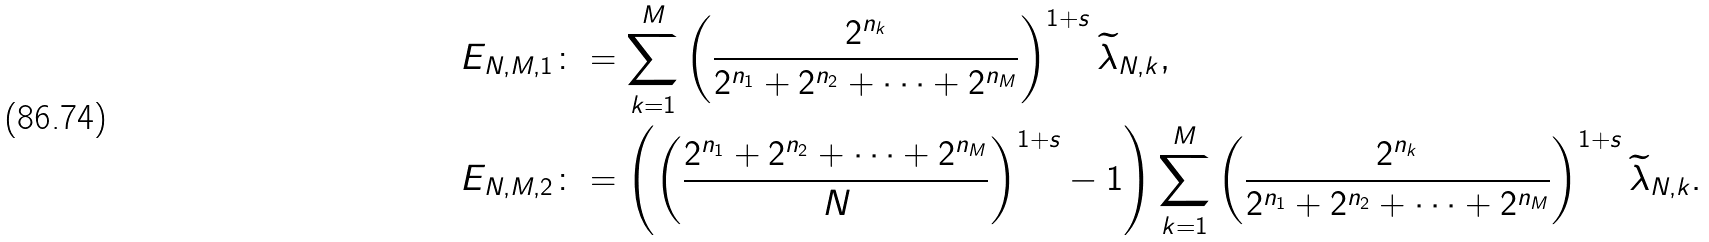<formula> <loc_0><loc_0><loc_500><loc_500>E _ { N , M , 1 } & \colon = \sum _ { k = 1 } ^ { M } \left ( \frac { 2 ^ { n _ { k } } } { 2 ^ { n _ { 1 } } + 2 ^ { n _ { 2 } } + \cdots + 2 ^ { n _ { M } } } \right ) ^ { 1 + s } \widetilde { \lambda } _ { N , k } , \\ E _ { N , M , 2 } & \colon = \left ( \left ( \frac { 2 ^ { n _ { 1 } } + 2 ^ { n _ { 2 } } + \cdots + 2 ^ { n _ { M } } } { N } \right ) ^ { 1 + s } - 1 \right ) \sum _ { k = 1 } ^ { M } \left ( \frac { 2 ^ { n _ { k } } } { 2 ^ { n _ { 1 } } + 2 ^ { n _ { 2 } } + \cdots + 2 ^ { n _ { M } } } \right ) ^ { 1 + s } \widetilde { \lambda } _ { N , k } .</formula> 